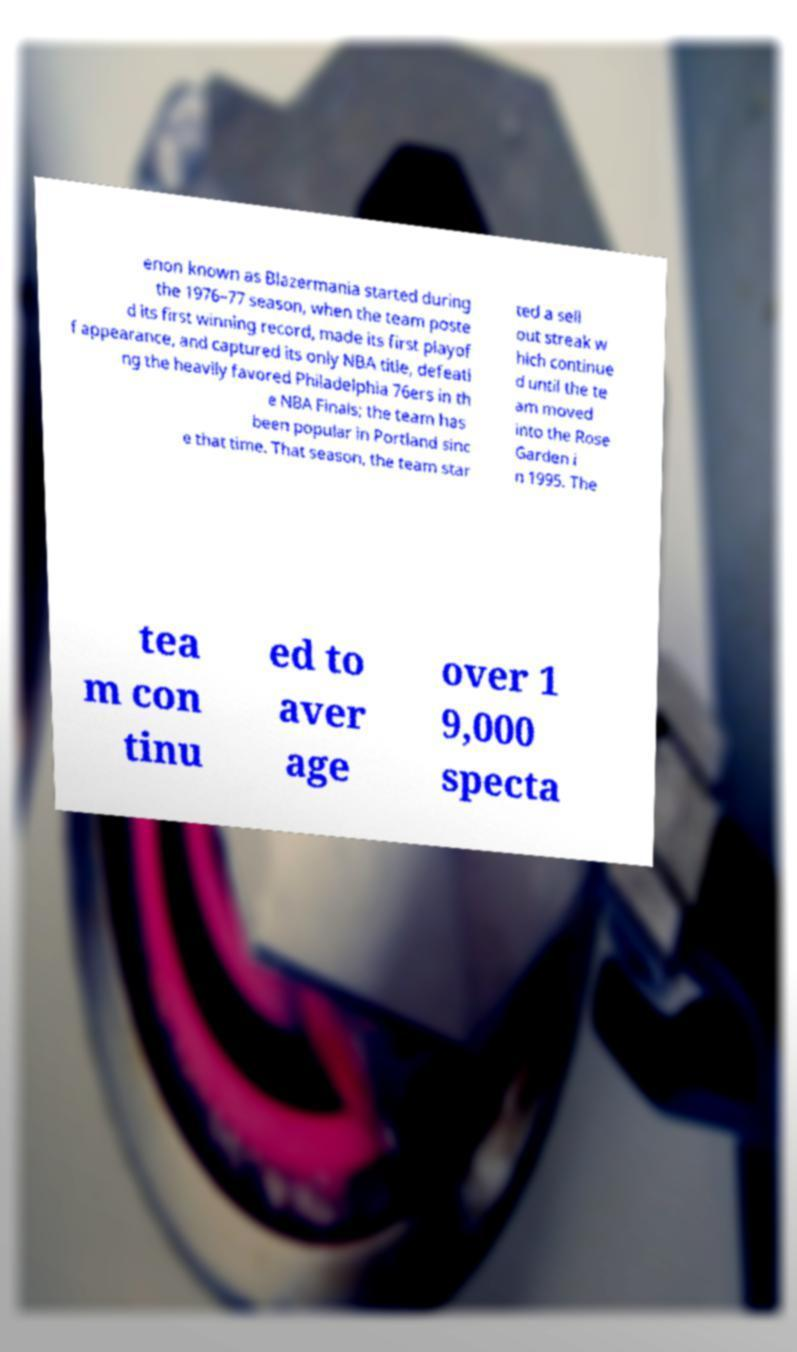There's text embedded in this image that I need extracted. Can you transcribe it verbatim? enon known as Blazermania started during the 1976–77 season, when the team poste d its first winning record, made its first playof f appearance, and captured its only NBA title, defeati ng the heavily favored Philadelphia 76ers in th e NBA Finals; the team has been popular in Portland sinc e that time. That season, the team star ted a sell out streak w hich continue d until the te am moved into the Rose Garden i n 1995. The tea m con tinu ed to aver age over 1 9,000 specta 